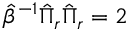Convert formula to latex. <formula><loc_0><loc_0><loc_500><loc_500>\hat { \beta } ^ { - 1 } \hat { \Pi } _ { r } \hat { \Pi } _ { r } = 2</formula> 